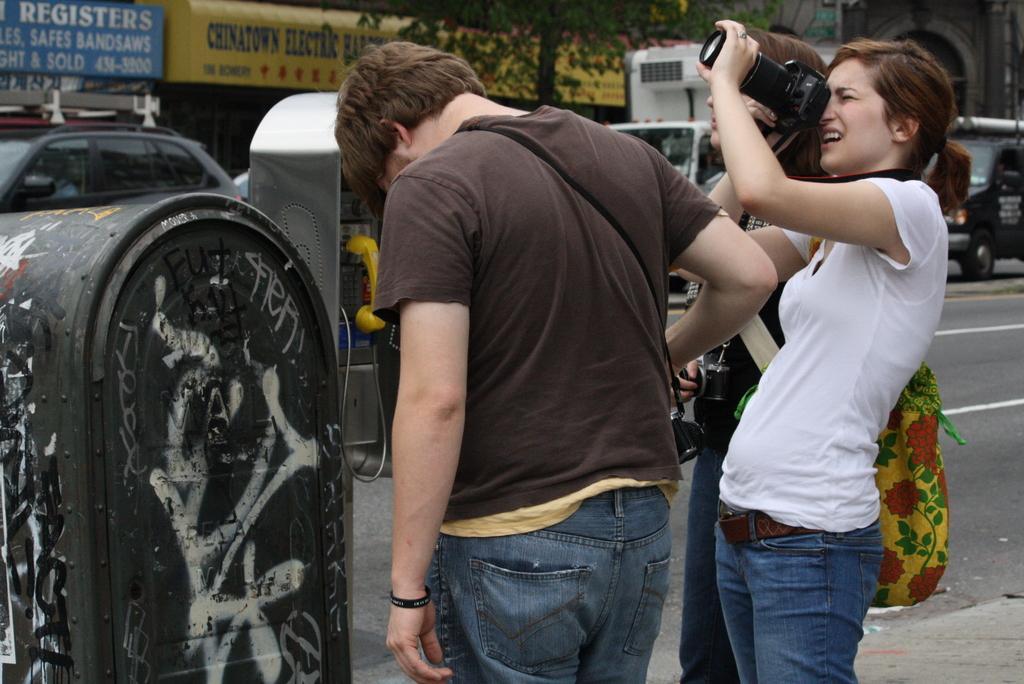How would you summarize this image in a sentence or two? In this image i can see the are the three persons standing on the road , a person wearing a white color t-shirt she holding a camera and her moth is open and back ground i can these are the hoarding boards and there is some text written on the hoarding board. And on the left corner i can see a car ,on the middle corner i can see a tree and on the right side corner i can see a vehicle on the road. 